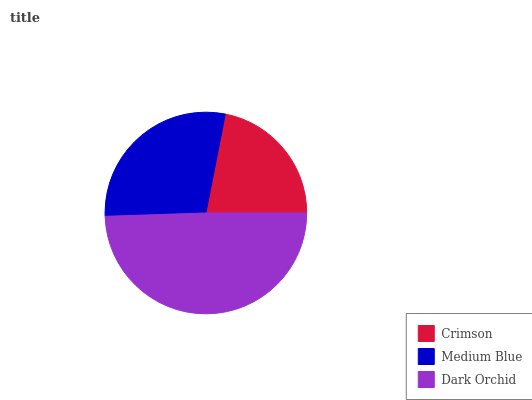Is Crimson the minimum?
Answer yes or no. Yes. Is Dark Orchid the maximum?
Answer yes or no. Yes. Is Medium Blue the minimum?
Answer yes or no. No. Is Medium Blue the maximum?
Answer yes or no. No. Is Medium Blue greater than Crimson?
Answer yes or no. Yes. Is Crimson less than Medium Blue?
Answer yes or no. Yes. Is Crimson greater than Medium Blue?
Answer yes or no. No. Is Medium Blue less than Crimson?
Answer yes or no. No. Is Medium Blue the high median?
Answer yes or no. Yes. Is Medium Blue the low median?
Answer yes or no. Yes. Is Dark Orchid the high median?
Answer yes or no. No. Is Crimson the low median?
Answer yes or no. No. 